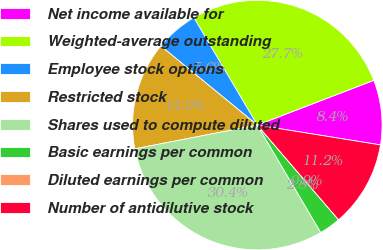Convert chart. <chart><loc_0><loc_0><loc_500><loc_500><pie_chart><fcel>Net income available for<fcel>Weighted-average outstanding<fcel>Employee stock options<fcel>Restricted stock<fcel>Shares used to compute diluted<fcel>Basic earnings per common<fcel>Diluted earnings per common<fcel>Number of antidilutive stock<nl><fcel>8.38%<fcel>27.65%<fcel>5.59%<fcel>13.97%<fcel>30.44%<fcel>2.79%<fcel>0.0%<fcel>11.17%<nl></chart> 